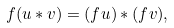<formula> <loc_0><loc_0><loc_500><loc_500>f ( u \ast v ) = ( f u ) \ast ( f v ) ,</formula> 